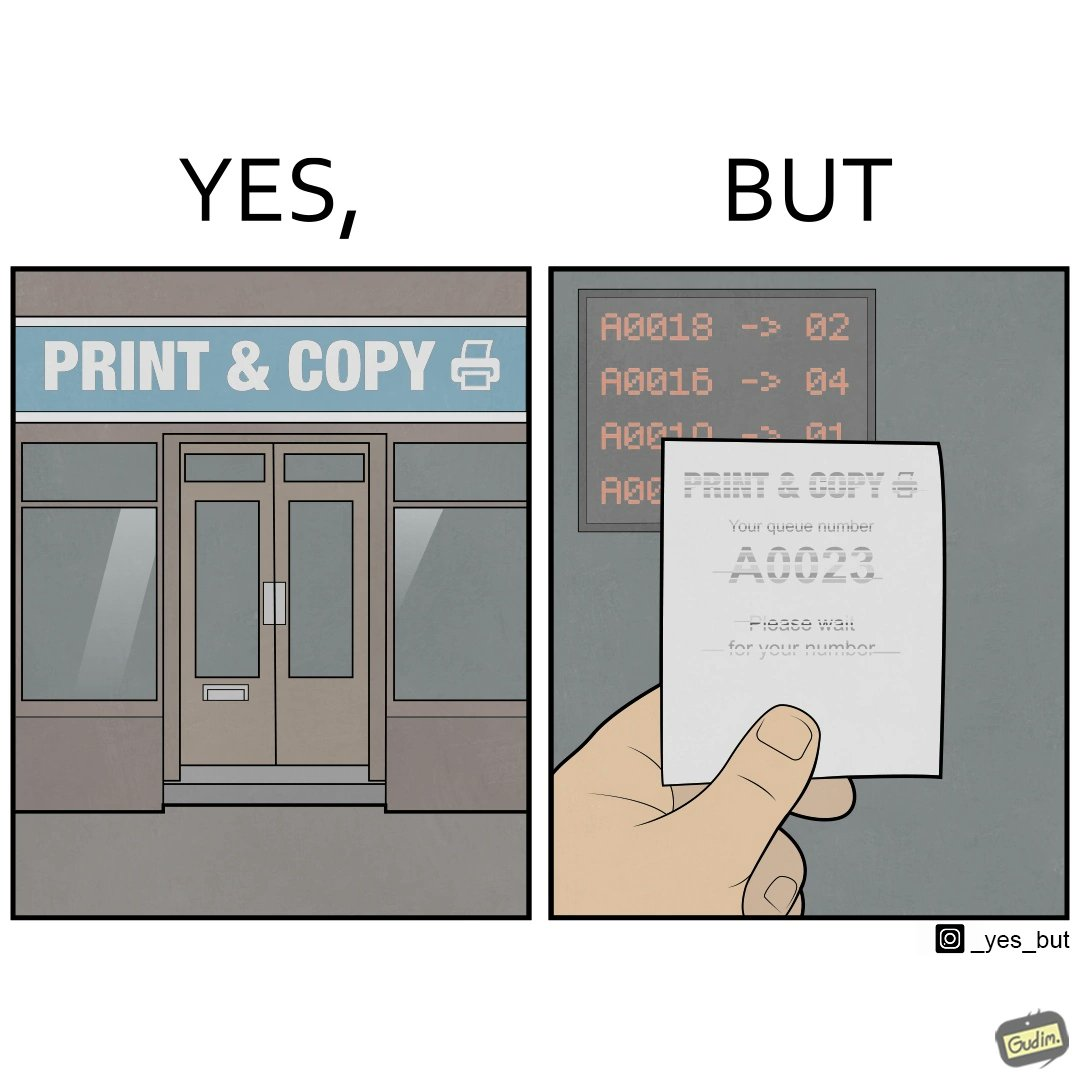Is there satirical content in this image? Yes, this image is satirical. 